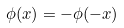Convert formula to latex. <formula><loc_0><loc_0><loc_500><loc_500>\phi ( x ) = - \phi ( - x )</formula> 